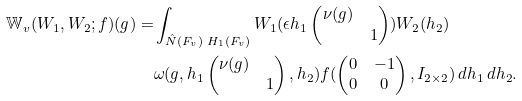<formula> <loc_0><loc_0><loc_500><loc_500>\mathbb { W } _ { v } ( W _ { 1 } , W _ { 2 } ; f ) ( g ) = & \int _ { \hat { N } ( F _ { v } ) \ H _ { 1 } ( F _ { v } ) } W _ { 1 } ( \epsilon h _ { 1 } \begin{pmatrix} \nu ( g ) \\ & 1 \end{pmatrix} ) W _ { 2 } ( h _ { 2 } ) \\ & \omega ( g , h _ { 1 } \begin{pmatrix} \nu ( g ) \\ & 1 \end{pmatrix} , h _ { 2 } ) f ( \begin{pmatrix} 0 & - 1 \\ 0 & 0 \end{pmatrix} , I _ { 2 \times 2 } ) \, d h _ { 1 } \, d h _ { 2 } .</formula> 